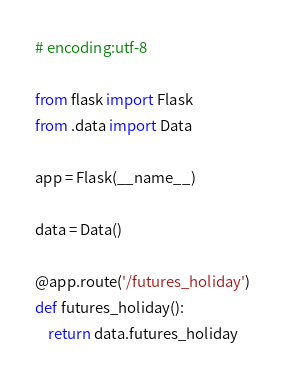Convert code to text. <code><loc_0><loc_0><loc_500><loc_500><_Python_># encoding:utf-8

from flask import Flask
from .data import Data

app = Flask(__name__)

data = Data()

@app.route('/futures_holiday')
def futures_holiday():
    return data.futures_holiday
</code> 